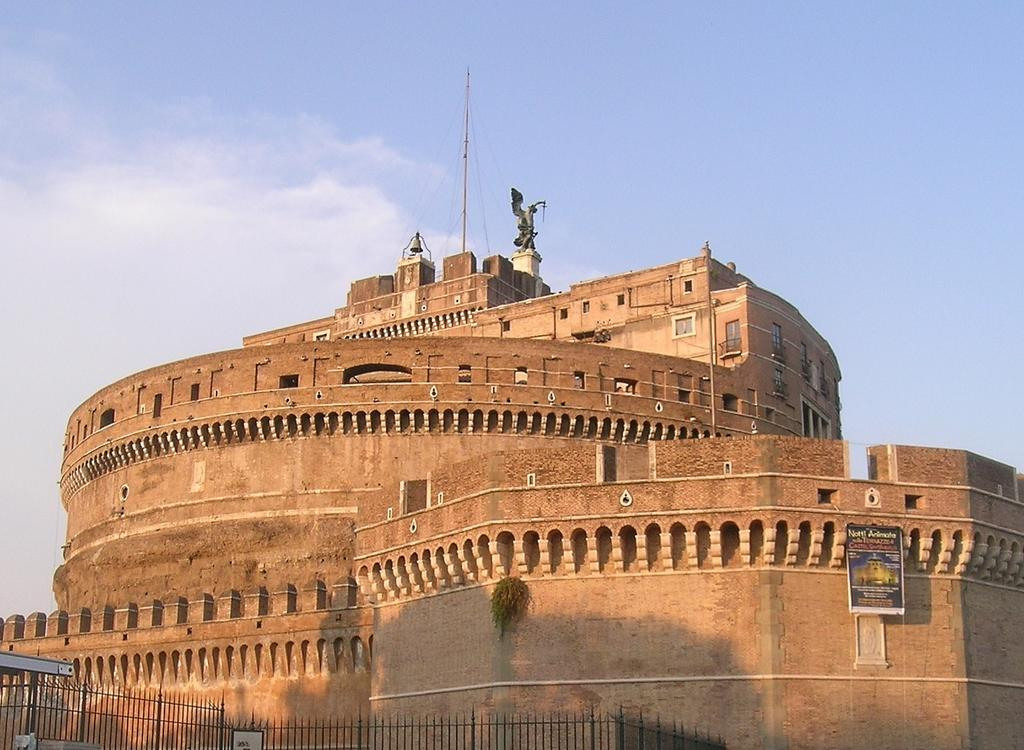What type of objects are located at the bottom of the image? There are metal rods at the bottom of the image. What is on the right side of the image? There is a hoarding on the right side of the image. What can be seen in the background of the image? There is a building and clouds visible in the background of the image. How many buns are stacked on top of the metal rods in the image? There are no buns present in the image; it features metal rods and a hoarding. What is the thumbprint used for in the image? There is no thumbprint visible in the image. 